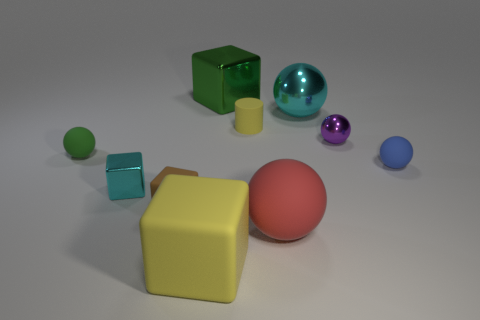Subtract all big rubber spheres. How many spheres are left? 4 Subtract all cyan blocks. How many blocks are left? 3 Subtract 1 cubes. How many cubes are left? 3 Subtract all gray blocks. How many green balls are left? 1 Subtract all metal objects. Subtract all yellow metal cylinders. How many objects are left? 6 Add 5 purple metallic spheres. How many purple metallic spheres are left? 6 Add 4 green metallic blocks. How many green metallic blocks exist? 5 Subtract 0 brown spheres. How many objects are left? 10 Subtract all cylinders. How many objects are left? 9 Subtract all green cubes. Subtract all yellow balls. How many cubes are left? 3 